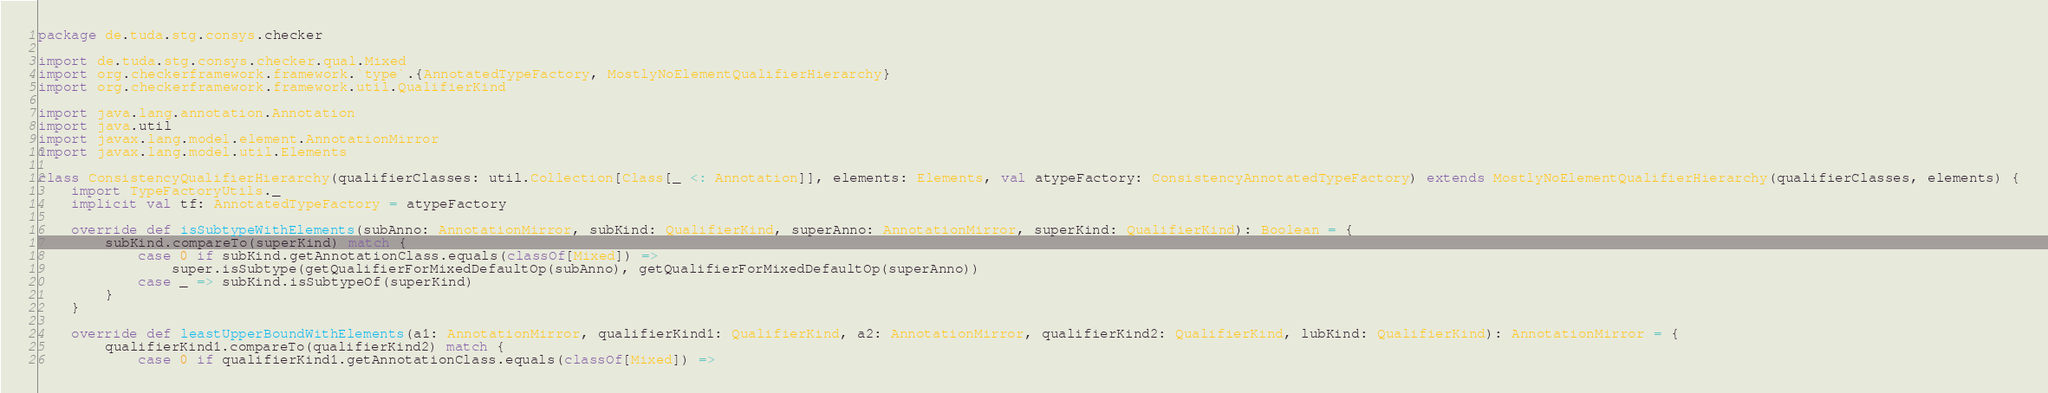<code> <loc_0><loc_0><loc_500><loc_500><_Scala_>package de.tuda.stg.consys.checker

import de.tuda.stg.consys.checker.qual.Mixed
import org.checkerframework.framework.`type`.{AnnotatedTypeFactory, MostlyNoElementQualifierHierarchy}
import org.checkerframework.framework.util.QualifierKind

import java.lang.annotation.Annotation
import java.util
import javax.lang.model.element.AnnotationMirror
import javax.lang.model.util.Elements

class ConsistencyQualifierHierarchy(qualifierClasses: util.Collection[Class[_ <: Annotation]], elements: Elements, val atypeFactory: ConsistencyAnnotatedTypeFactory) extends MostlyNoElementQualifierHierarchy(qualifierClasses, elements) {
    import TypeFactoryUtils._
    implicit val tf: AnnotatedTypeFactory = atypeFactory

    override def isSubtypeWithElements(subAnno: AnnotationMirror, subKind: QualifierKind, superAnno: AnnotationMirror, superKind: QualifierKind): Boolean = {
        subKind.compareTo(superKind) match {
            case 0 if subKind.getAnnotationClass.equals(classOf[Mixed]) =>
                super.isSubtype(getQualifierForMixedDefaultOp(subAnno), getQualifierForMixedDefaultOp(superAnno))
            case _ => subKind.isSubtypeOf(superKind)
        }
    }

    override def leastUpperBoundWithElements(a1: AnnotationMirror, qualifierKind1: QualifierKind, a2: AnnotationMirror, qualifierKind2: QualifierKind, lubKind: QualifierKind): AnnotationMirror = {
        qualifierKind1.compareTo(qualifierKind2) match {
            case 0 if qualifierKind1.getAnnotationClass.equals(classOf[Mixed]) =></code> 